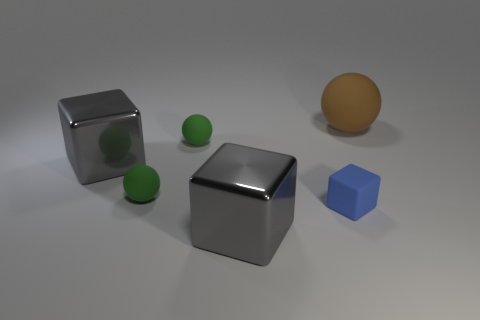There is a gray object in front of the small blue matte block; is its size the same as the shiny cube that is behind the blue rubber thing?
Give a very brief answer. Yes. How many spheres are either brown matte objects or large objects?
Your answer should be compact. 1. What number of metal objects are either blocks or big objects?
Provide a succinct answer. 2. Are there any other things that are the same size as the brown rubber thing?
Give a very brief answer. Yes. There is a brown object; does it have the same size as the shiny thing behind the tiny blue block?
Keep it short and to the point. Yes. What shape is the metallic thing that is behind the small cube?
Provide a succinct answer. Cube. What color is the big metal object on the right side of the gray metal block behind the tiny blue matte block?
Offer a terse response. Gray. There is a large matte object; is its color the same as the large metal object in front of the blue matte block?
Your answer should be compact. No. What material is the gray object in front of the gray object that is to the left of the large gray cube in front of the blue object?
Provide a short and direct response. Metal. Are there more small blue rubber objects right of the blue rubber thing than shiny things that are behind the brown matte thing?
Offer a very short reply. No. 